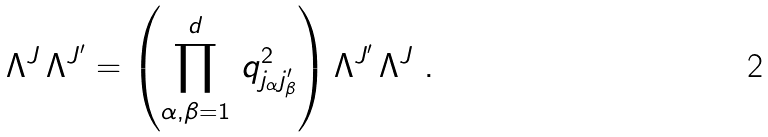<formula> <loc_0><loc_0><loc_500><loc_500>\Lambda ^ { J } \, \Lambda ^ { J ^ { \prime } } = \left ( \prod _ { \alpha , \beta = 1 } ^ { d } \, q ^ { 2 } _ { j _ { \alpha } j ^ { \prime } _ { \beta } } \right ) \Lambda ^ { J ^ { \prime } } \, \Lambda ^ { J } \ .</formula> 